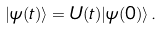Convert formula to latex. <formula><loc_0><loc_0><loc_500><loc_500>| \psi ( t ) \rangle = U ( t ) | \psi ( 0 ) \rangle \, .</formula> 